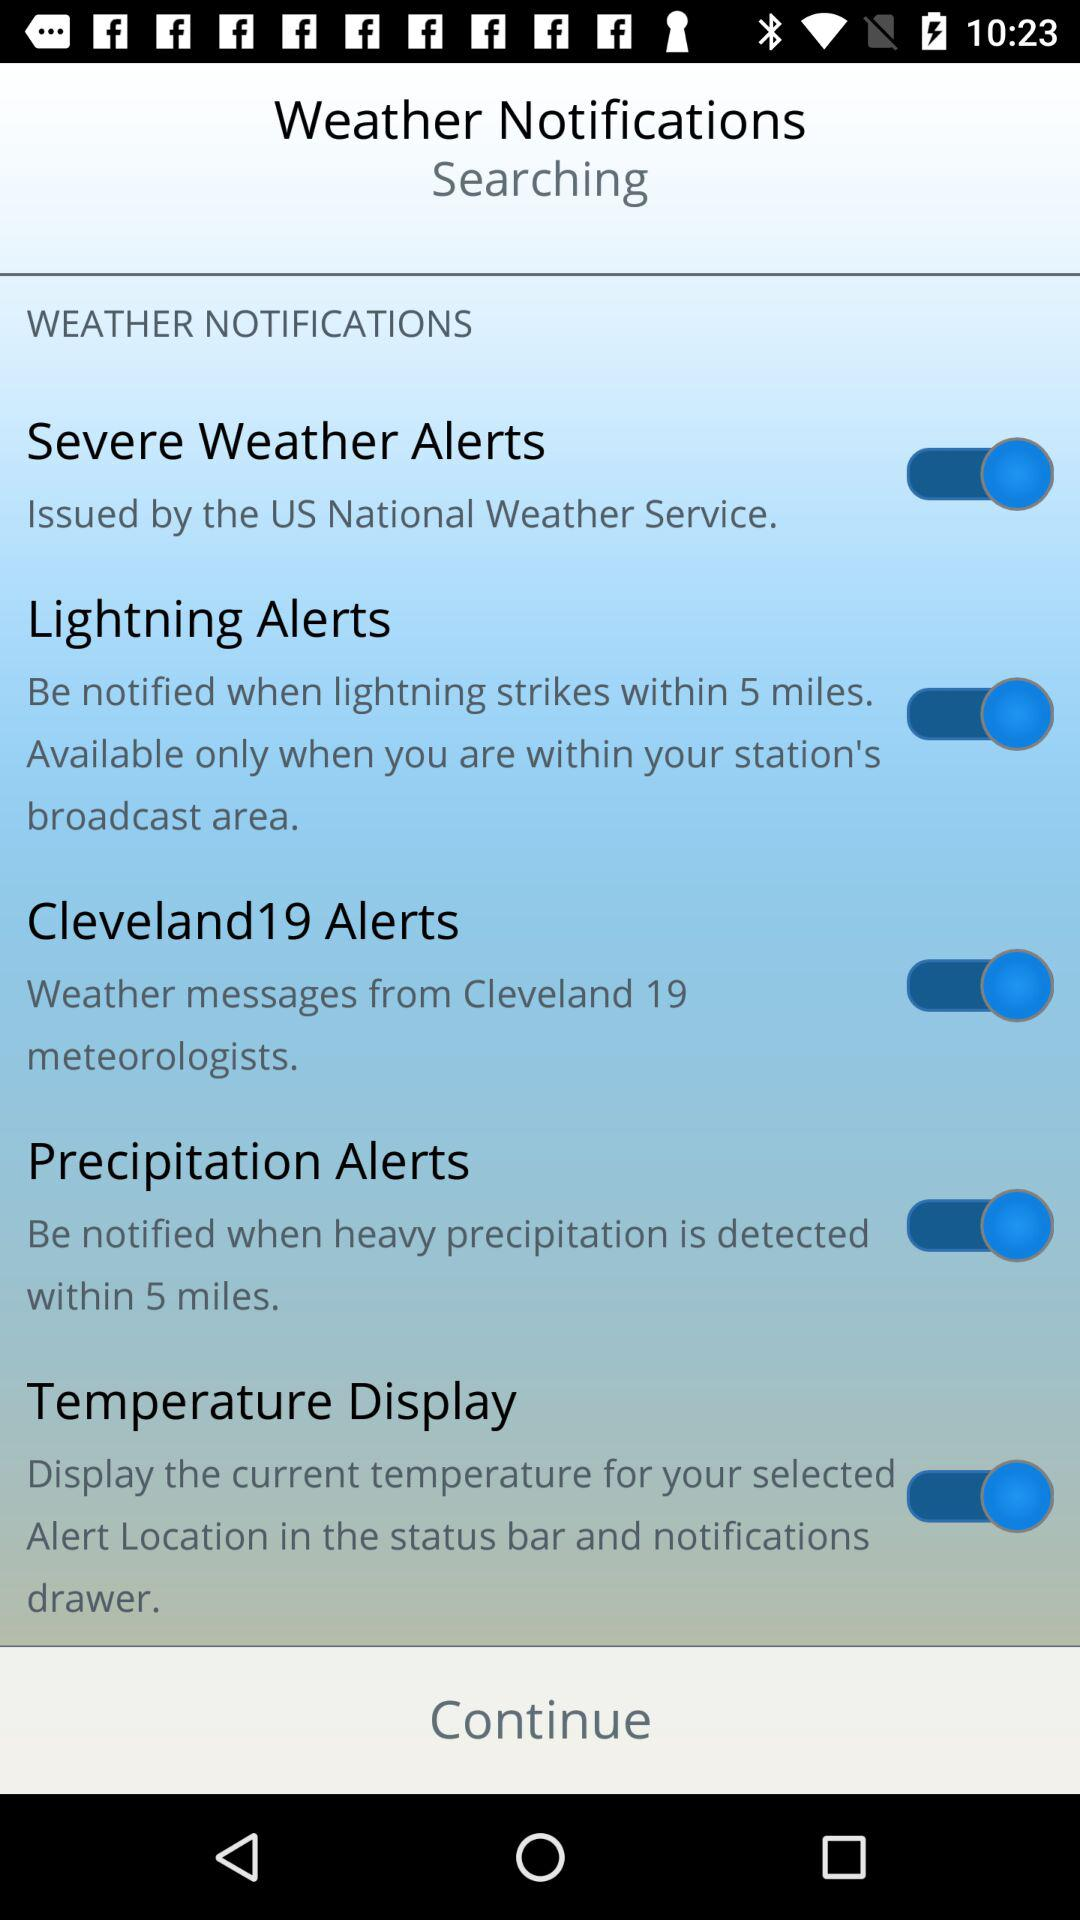What is the status of "Precipitation Alerts"? The status is "on". 